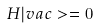<formula> <loc_0><loc_0><loc_500><loc_500>H | v a c > = 0</formula> 